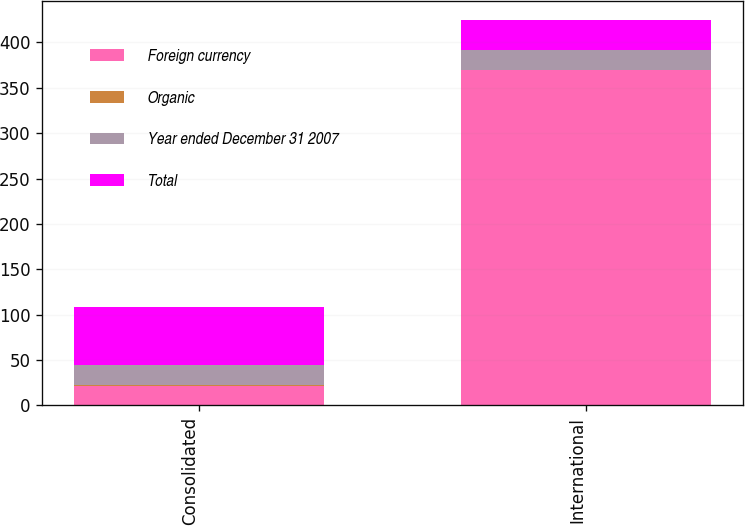Convert chart. <chart><loc_0><loc_0><loc_500><loc_500><stacked_bar_chart><ecel><fcel>Consolidated<fcel>International<nl><fcel>Foreign currency<fcel>21.8<fcel>369.3<nl><fcel>Organic<fcel>0.7<fcel>0.7<nl><fcel>Year ended December 31 2007<fcel>21.8<fcel>21.8<nl><fcel>Total<fcel>64.6<fcel>32.9<nl></chart> 